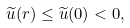<formula> <loc_0><loc_0><loc_500><loc_500>\widetilde { u } ( r ) \leq \widetilde { u } ( 0 ) < 0 ,</formula> 